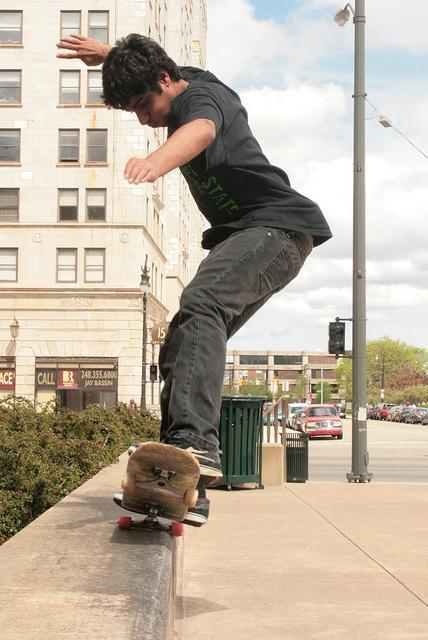How many people are visible?
Give a very brief answer. 1. 